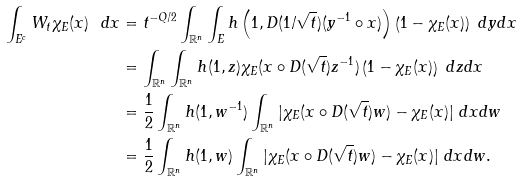Convert formula to latex. <formula><loc_0><loc_0><loc_500><loc_500>\int _ { E ^ { c } } W _ { t } \chi _ { E } ( x ) \ d x & = t ^ { - Q / 2 } \int _ { { \mathbb { R } } ^ { n } } \int _ { E } h \left ( 1 , D ( 1 / \sqrt { t } ) ( y ^ { - 1 } \circ x ) \right ) \left ( 1 - \chi _ { E } ( x ) \right ) \ d y d x \\ & = \int _ { { \mathbb { R } } ^ { n } } \int _ { { \mathbb { R } } ^ { n } } h ( 1 , z ) \chi _ { E } ( x \circ D ( \sqrt { t } ) z ^ { - 1 } ) \left ( 1 - \chi _ { E } ( x ) \right ) \ d z d x \\ & = \frac { 1 } { 2 } \int _ { { \mathbb { R } } ^ { n } } h ( 1 , w ^ { - 1 } ) \int _ { { \mathbb { R } } ^ { n } } | \chi _ { E } ( x \circ D ( \sqrt { t } ) w ) - \chi _ { E } ( x ) | \ d x d w \\ & = \frac { 1 } { 2 } \int _ { { \mathbb { R } } ^ { n } } h ( 1 , w ) \int _ { { \mathbb { R } } ^ { n } } | \chi _ { E } ( x \circ D ( \sqrt { t } ) w ) - \chi _ { E } ( x ) | \ d x d w .</formula> 